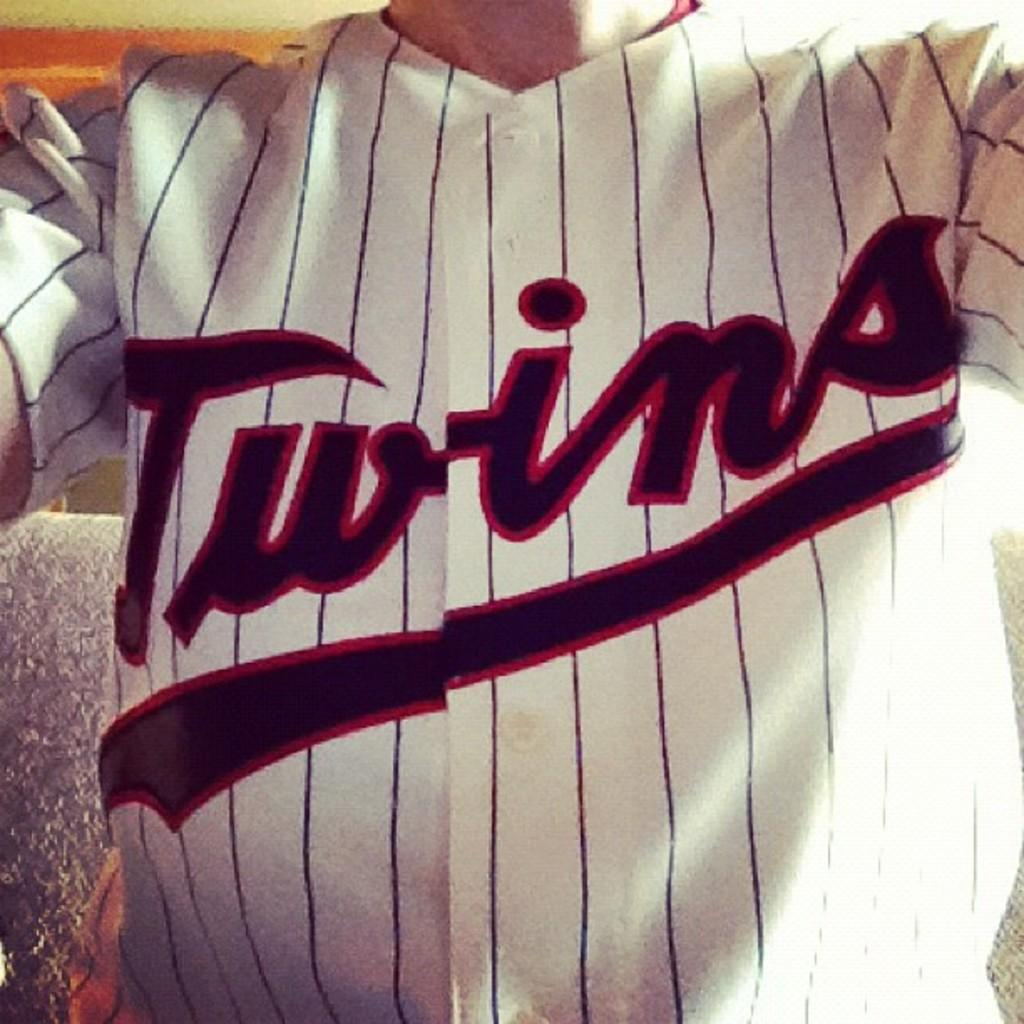Provide a one-sentence caption for the provided image. A close up of a person where only the torso is visible is wearing a Twins jersey. 